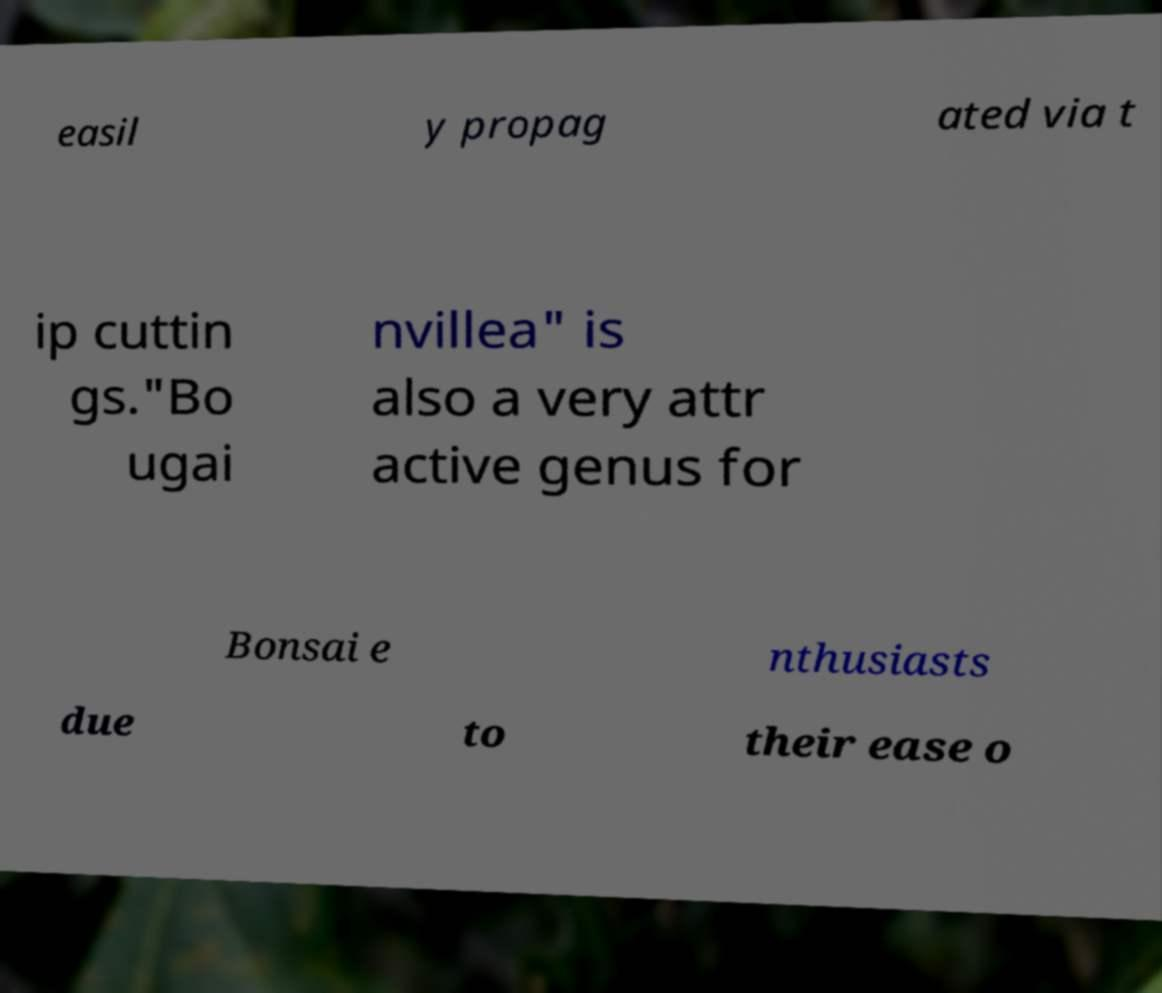There's text embedded in this image that I need extracted. Can you transcribe it verbatim? easil y propag ated via t ip cuttin gs."Bo ugai nvillea" is also a very attr active genus for Bonsai e nthusiasts due to their ease o 